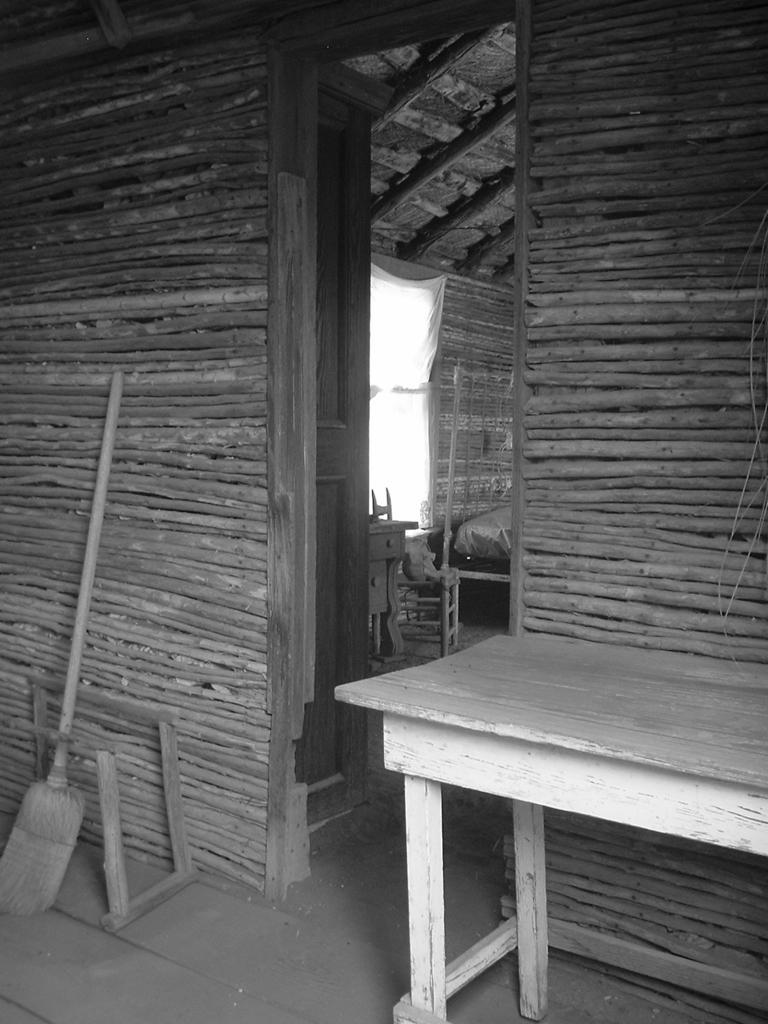Could you give a brief overview of what you see in this image? This is a black and white picture, there is a wooden home in the back with a table and broom stick in front of it. 